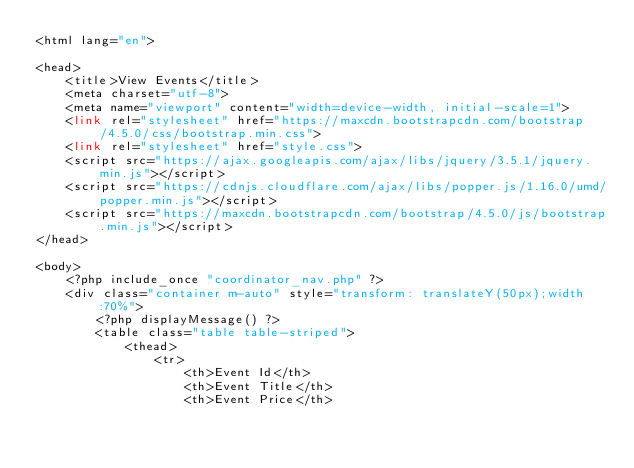<code> <loc_0><loc_0><loc_500><loc_500><_PHP_><html lang="en">

<head>
    <title>View Events</title>
    <meta charset="utf-8">
    <meta name="viewport" content="width=device-width, initial-scale=1">
    <link rel="stylesheet" href="https://maxcdn.bootstrapcdn.com/bootstrap/4.5.0/css/bootstrap.min.css">
    <link rel="stylesheet" href="style.css">
    <script src="https://ajax.googleapis.com/ajax/libs/jquery/3.5.1/jquery.min.js"></script>
    <script src="https://cdnjs.cloudflare.com/ajax/libs/popper.js/1.16.0/umd/popper.min.js"></script>
    <script src="https://maxcdn.bootstrapcdn.com/bootstrap/4.5.0/js/bootstrap.min.js"></script>
</head>

<body>
    <?php include_once "coordinator_nav.php" ?>
    <div class="container m-auto" style="transform: translateY(50px);width:70%">
        <?php displayMessage() ?>
        <table class="table table-striped">
            <thead>
                <tr>
                    <th>Event Id</th>
                    <th>Event Title</th>
                    <th>Event Price</th></code> 